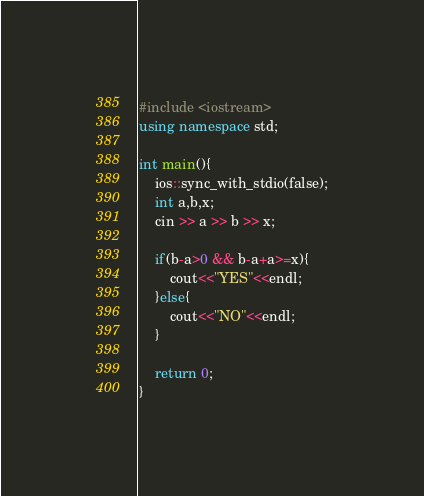<code> <loc_0><loc_0><loc_500><loc_500><_C++_>#include <iostream>
using namespace std;

int main(){
    ios::sync_with_stdio(false);
    int a,b,x;
    cin >> a >> b >> x;

    if(b-a>0 && b-a+a>=x){
        cout<<"YES"<<endl;
    }else{
        cout<<"NO"<<endl;
    }

    return 0;
}
</code> 